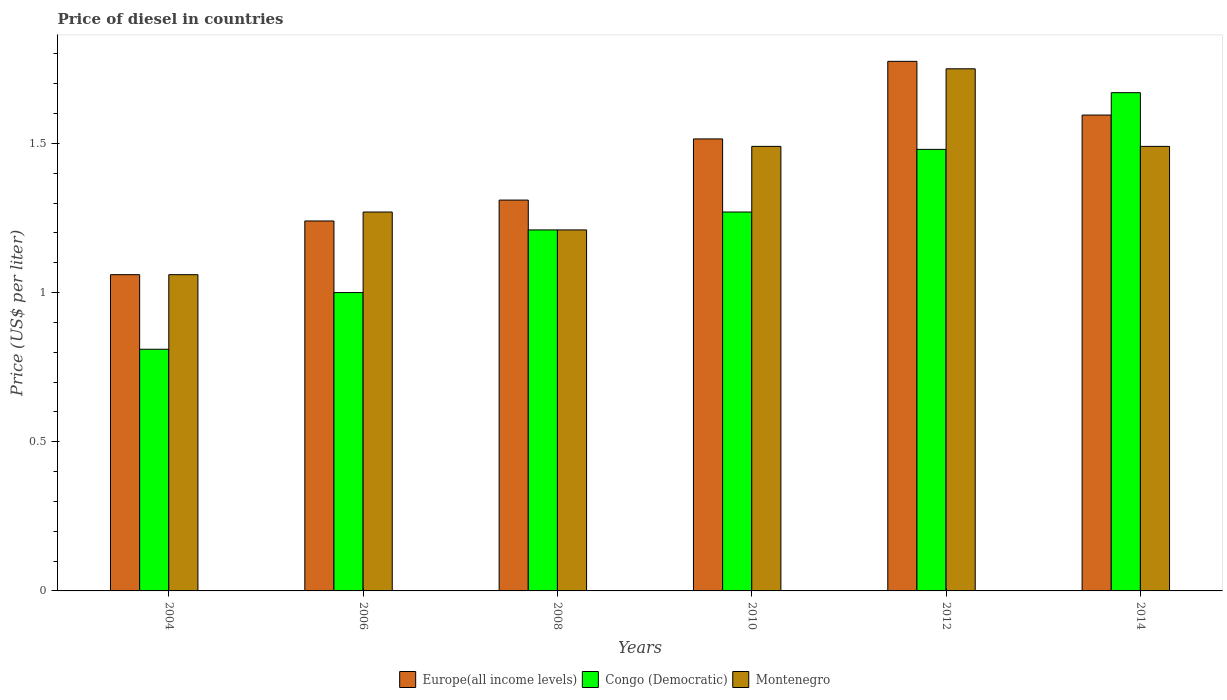How many groups of bars are there?
Your response must be concise. 6. Are the number of bars on each tick of the X-axis equal?
Keep it short and to the point. Yes. What is the price of diesel in Congo (Democratic) in 2004?
Offer a terse response. 0.81. Across all years, what is the maximum price of diesel in Congo (Democratic)?
Ensure brevity in your answer.  1.67. Across all years, what is the minimum price of diesel in Congo (Democratic)?
Keep it short and to the point. 0.81. What is the total price of diesel in Europe(all income levels) in the graph?
Offer a very short reply. 8.5. What is the difference between the price of diesel in Europe(all income levels) in 2006 and that in 2008?
Ensure brevity in your answer.  -0.07. What is the difference between the price of diesel in Congo (Democratic) in 2010 and the price of diesel in Europe(all income levels) in 2006?
Offer a very short reply. 0.03. What is the average price of diesel in Europe(all income levels) per year?
Give a very brief answer. 1.42. In the year 2010, what is the difference between the price of diesel in Congo (Democratic) and price of diesel in Europe(all income levels)?
Make the answer very short. -0.24. In how many years, is the price of diesel in Europe(all income levels) greater than 0.9 US$?
Provide a short and direct response. 6. What is the ratio of the price of diesel in Congo (Democratic) in 2004 to that in 2014?
Offer a very short reply. 0.49. Is the difference between the price of diesel in Congo (Democratic) in 2010 and 2012 greater than the difference between the price of diesel in Europe(all income levels) in 2010 and 2012?
Make the answer very short. Yes. What is the difference between the highest and the second highest price of diesel in Montenegro?
Make the answer very short. 0.26. What is the difference between the highest and the lowest price of diesel in Montenegro?
Give a very brief answer. 0.69. Is the sum of the price of diesel in Montenegro in 2010 and 2012 greater than the maximum price of diesel in Congo (Democratic) across all years?
Offer a very short reply. Yes. What does the 1st bar from the left in 2006 represents?
Provide a short and direct response. Europe(all income levels). What does the 3rd bar from the right in 2008 represents?
Your answer should be very brief. Europe(all income levels). Is it the case that in every year, the sum of the price of diesel in Europe(all income levels) and price of diesel in Congo (Democratic) is greater than the price of diesel in Montenegro?
Offer a very short reply. Yes. Are all the bars in the graph horizontal?
Provide a short and direct response. No. How many years are there in the graph?
Provide a succinct answer. 6. What is the difference between two consecutive major ticks on the Y-axis?
Your response must be concise. 0.5. Are the values on the major ticks of Y-axis written in scientific E-notation?
Your response must be concise. No. Does the graph contain grids?
Your answer should be very brief. No. How many legend labels are there?
Offer a terse response. 3. What is the title of the graph?
Offer a terse response. Price of diesel in countries. Does "India" appear as one of the legend labels in the graph?
Offer a terse response. No. What is the label or title of the Y-axis?
Provide a short and direct response. Price (US$ per liter). What is the Price (US$ per liter) in Europe(all income levels) in 2004?
Offer a terse response. 1.06. What is the Price (US$ per liter) in Congo (Democratic) in 2004?
Give a very brief answer. 0.81. What is the Price (US$ per liter) of Montenegro in 2004?
Your response must be concise. 1.06. What is the Price (US$ per liter) of Europe(all income levels) in 2006?
Ensure brevity in your answer.  1.24. What is the Price (US$ per liter) in Congo (Democratic) in 2006?
Offer a very short reply. 1. What is the Price (US$ per liter) of Montenegro in 2006?
Your answer should be compact. 1.27. What is the Price (US$ per liter) in Europe(all income levels) in 2008?
Your response must be concise. 1.31. What is the Price (US$ per liter) of Congo (Democratic) in 2008?
Your answer should be compact. 1.21. What is the Price (US$ per liter) in Montenegro in 2008?
Ensure brevity in your answer.  1.21. What is the Price (US$ per liter) in Europe(all income levels) in 2010?
Offer a terse response. 1.51. What is the Price (US$ per liter) of Congo (Democratic) in 2010?
Offer a terse response. 1.27. What is the Price (US$ per liter) in Montenegro in 2010?
Your answer should be very brief. 1.49. What is the Price (US$ per liter) of Europe(all income levels) in 2012?
Your answer should be compact. 1.77. What is the Price (US$ per liter) of Congo (Democratic) in 2012?
Make the answer very short. 1.48. What is the Price (US$ per liter) of Montenegro in 2012?
Make the answer very short. 1.75. What is the Price (US$ per liter) in Europe(all income levels) in 2014?
Provide a short and direct response. 1.59. What is the Price (US$ per liter) of Congo (Democratic) in 2014?
Your response must be concise. 1.67. What is the Price (US$ per liter) in Montenegro in 2014?
Give a very brief answer. 1.49. Across all years, what is the maximum Price (US$ per liter) in Europe(all income levels)?
Make the answer very short. 1.77. Across all years, what is the maximum Price (US$ per liter) of Congo (Democratic)?
Your response must be concise. 1.67. Across all years, what is the maximum Price (US$ per liter) of Montenegro?
Keep it short and to the point. 1.75. Across all years, what is the minimum Price (US$ per liter) in Europe(all income levels)?
Give a very brief answer. 1.06. Across all years, what is the minimum Price (US$ per liter) in Congo (Democratic)?
Your answer should be compact. 0.81. Across all years, what is the minimum Price (US$ per liter) of Montenegro?
Your answer should be very brief. 1.06. What is the total Price (US$ per liter) in Europe(all income levels) in the graph?
Make the answer very short. 8.49. What is the total Price (US$ per liter) of Congo (Democratic) in the graph?
Give a very brief answer. 7.44. What is the total Price (US$ per liter) of Montenegro in the graph?
Your answer should be compact. 8.27. What is the difference between the Price (US$ per liter) in Europe(all income levels) in 2004 and that in 2006?
Make the answer very short. -0.18. What is the difference between the Price (US$ per liter) of Congo (Democratic) in 2004 and that in 2006?
Keep it short and to the point. -0.19. What is the difference between the Price (US$ per liter) in Montenegro in 2004 and that in 2006?
Offer a very short reply. -0.21. What is the difference between the Price (US$ per liter) of Europe(all income levels) in 2004 and that in 2008?
Make the answer very short. -0.25. What is the difference between the Price (US$ per liter) in Europe(all income levels) in 2004 and that in 2010?
Make the answer very short. -0.46. What is the difference between the Price (US$ per liter) in Congo (Democratic) in 2004 and that in 2010?
Offer a very short reply. -0.46. What is the difference between the Price (US$ per liter) in Montenegro in 2004 and that in 2010?
Give a very brief answer. -0.43. What is the difference between the Price (US$ per liter) in Europe(all income levels) in 2004 and that in 2012?
Ensure brevity in your answer.  -0.71. What is the difference between the Price (US$ per liter) in Congo (Democratic) in 2004 and that in 2012?
Your answer should be compact. -0.67. What is the difference between the Price (US$ per liter) of Montenegro in 2004 and that in 2012?
Offer a terse response. -0.69. What is the difference between the Price (US$ per liter) of Europe(all income levels) in 2004 and that in 2014?
Offer a terse response. -0.54. What is the difference between the Price (US$ per liter) of Congo (Democratic) in 2004 and that in 2014?
Your response must be concise. -0.86. What is the difference between the Price (US$ per liter) in Montenegro in 2004 and that in 2014?
Offer a very short reply. -0.43. What is the difference between the Price (US$ per liter) in Europe(all income levels) in 2006 and that in 2008?
Make the answer very short. -0.07. What is the difference between the Price (US$ per liter) in Congo (Democratic) in 2006 and that in 2008?
Your answer should be very brief. -0.21. What is the difference between the Price (US$ per liter) in Europe(all income levels) in 2006 and that in 2010?
Keep it short and to the point. -0.28. What is the difference between the Price (US$ per liter) of Congo (Democratic) in 2006 and that in 2010?
Your response must be concise. -0.27. What is the difference between the Price (US$ per liter) in Montenegro in 2006 and that in 2010?
Provide a succinct answer. -0.22. What is the difference between the Price (US$ per liter) of Europe(all income levels) in 2006 and that in 2012?
Your answer should be very brief. -0.54. What is the difference between the Price (US$ per liter) in Congo (Democratic) in 2006 and that in 2012?
Your answer should be very brief. -0.48. What is the difference between the Price (US$ per liter) in Montenegro in 2006 and that in 2012?
Your answer should be compact. -0.48. What is the difference between the Price (US$ per liter) of Europe(all income levels) in 2006 and that in 2014?
Ensure brevity in your answer.  -0.35. What is the difference between the Price (US$ per liter) in Congo (Democratic) in 2006 and that in 2014?
Offer a terse response. -0.67. What is the difference between the Price (US$ per liter) in Montenegro in 2006 and that in 2014?
Offer a terse response. -0.22. What is the difference between the Price (US$ per liter) of Europe(all income levels) in 2008 and that in 2010?
Keep it short and to the point. -0.2. What is the difference between the Price (US$ per liter) of Congo (Democratic) in 2008 and that in 2010?
Your answer should be compact. -0.06. What is the difference between the Price (US$ per liter) of Montenegro in 2008 and that in 2010?
Provide a short and direct response. -0.28. What is the difference between the Price (US$ per liter) in Europe(all income levels) in 2008 and that in 2012?
Your answer should be compact. -0.47. What is the difference between the Price (US$ per liter) of Congo (Democratic) in 2008 and that in 2012?
Provide a succinct answer. -0.27. What is the difference between the Price (US$ per liter) of Montenegro in 2008 and that in 2012?
Your answer should be compact. -0.54. What is the difference between the Price (US$ per liter) in Europe(all income levels) in 2008 and that in 2014?
Your response must be concise. -0.28. What is the difference between the Price (US$ per liter) in Congo (Democratic) in 2008 and that in 2014?
Give a very brief answer. -0.46. What is the difference between the Price (US$ per liter) in Montenegro in 2008 and that in 2014?
Ensure brevity in your answer.  -0.28. What is the difference between the Price (US$ per liter) of Europe(all income levels) in 2010 and that in 2012?
Ensure brevity in your answer.  -0.26. What is the difference between the Price (US$ per liter) in Congo (Democratic) in 2010 and that in 2012?
Your answer should be compact. -0.21. What is the difference between the Price (US$ per liter) in Montenegro in 2010 and that in 2012?
Your answer should be compact. -0.26. What is the difference between the Price (US$ per liter) of Europe(all income levels) in 2010 and that in 2014?
Provide a short and direct response. -0.08. What is the difference between the Price (US$ per liter) of Montenegro in 2010 and that in 2014?
Offer a terse response. 0. What is the difference between the Price (US$ per liter) in Europe(all income levels) in 2012 and that in 2014?
Provide a succinct answer. 0.18. What is the difference between the Price (US$ per liter) of Congo (Democratic) in 2012 and that in 2014?
Provide a succinct answer. -0.19. What is the difference between the Price (US$ per liter) in Montenegro in 2012 and that in 2014?
Give a very brief answer. 0.26. What is the difference between the Price (US$ per liter) of Europe(all income levels) in 2004 and the Price (US$ per liter) of Montenegro in 2006?
Your answer should be compact. -0.21. What is the difference between the Price (US$ per liter) of Congo (Democratic) in 2004 and the Price (US$ per liter) of Montenegro in 2006?
Keep it short and to the point. -0.46. What is the difference between the Price (US$ per liter) of Europe(all income levels) in 2004 and the Price (US$ per liter) of Congo (Democratic) in 2008?
Offer a terse response. -0.15. What is the difference between the Price (US$ per liter) of Congo (Democratic) in 2004 and the Price (US$ per liter) of Montenegro in 2008?
Keep it short and to the point. -0.4. What is the difference between the Price (US$ per liter) in Europe(all income levels) in 2004 and the Price (US$ per liter) in Congo (Democratic) in 2010?
Your answer should be very brief. -0.21. What is the difference between the Price (US$ per liter) of Europe(all income levels) in 2004 and the Price (US$ per liter) of Montenegro in 2010?
Make the answer very short. -0.43. What is the difference between the Price (US$ per liter) of Congo (Democratic) in 2004 and the Price (US$ per liter) of Montenegro in 2010?
Provide a short and direct response. -0.68. What is the difference between the Price (US$ per liter) in Europe(all income levels) in 2004 and the Price (US$ per liter) in Congo (Democratic) in 2012?
Offer a terse response. -0.42. What is the difference between the Price (US$ per liter) of Europe(all income levels) in 2004 and the Price (US$ per liter) of Montenegro in 2012?
Make the answer very short. -0.69. What is the difference between the Price (US$ per liter) in Congo (Democratic) in 2004 and the Price (US$ per liter) in Montenegro in 2012?
Offer a terse response. -0.94. What is the difference between the Price (US$ per liter) in Europe(all income levels) in 2004 and the Price (US$ per liter) in Congo (Democratic) in 2014?
Your response must be concise. -0.61. What is the difference between the Price (US$ per liter) of Europe(all income levels) in 2004 and the Price (US$ per liter) of Montenegro in 2014?
Ensure brevity in your answer.  -0.43. What is the difference between the Price (US$ per liter) in Congo (Democratic) in 2004 and the Price (US$ per liter) in Montenegro in 2014?
Your response must be concise. -0.68. What is the difference between the Price (US$ per liter) of Europe(all income levels) in 2006 and the Price (US$ per liter) of Congo (Democratic) in 2008?
Offer a terse response. 0.03. What is the difference between the Price (US$ per liter) of Europe(all income levels) in 2006 and the Price (US$ per liter) of Montenegro in 2008?
Offer a terse response. 0.03. What is the difference between the Price (US$ per liter) of Congo (Democratic) in 2006 and the Price (US$ per liter) of Montenegro in 2008?
Offer a terse response. -0.21. What is the difference between the Price (US$ per liter) of Europe(all income levels) in 2006 and the Price (US$ per liter) of Congo (Democratic) in 2010?
Your response must be concise. -0.03. What is the difference between the Price (US$ per liter) of Congo (Democratic) in 2006 and the Price (US$ per liter) of Montenegro in 2010?
Your answer should be compact. -0.49. What is the difference between the Price (US$ per liter) of Europe(all income levels) in 2006 and the Price (US$ per liter) of Congo (Democratic) in 2012?
Your answer should be very brief. -0.24. What is the difference between the Price (US$ per liter) of Europe(all income levels) in 2006 and the Price (US$ per liter) of Montenegro in 2012?
Make the answer very short. -0.51. What is the difference between the Price (US$ per liter) of Congo (Democratic) in 2006 and the Price (US$ per liter) of Montenegro in 2012?
Keep it short and to the point. -0.75. What is the difference between the Price (US$ per liter) of Europe(all income levels) in 2006 and the Price (US$ per liter) of Congo (Democratic) in 2014?
Make the answer very short. -0.43. What is the difference between the Price (US$ per liter) in Europe(all income levels) in 2006 and the Price (US$ per liter) in Montenegro in 2014?
Offer a very short reply. -0.25. What is the difference between the Price (US$ per liter) of Congo (Democratic) in 2006 and the Price (US$ per liter) of Montenegro in 2014?
Provide a short and direct response. -0.49. What is the difference between the Price (US$ per liter) in Europe(all income levels) in 2008 and the Price (US$ per liter) in Montenegro in 2010?
Make the answer very short. -0.18. What is the difference between the Price (US$ per liter) in Congo (Democratic) in 2008 and the Price (US$ per liter) in Montenegro in 2010?
Your answer should be compact. -0.28. What is the difference between the Price (US$ per liter) in Europe(all income levels) in 2008 and the Price (US$ per liter) in Congo (Democratic) in 2012?
Provide a succinct answer. -0.17. What is the difference between the Price (US$ per liter) of Europe(all income levels) in 2008 and the Price (US$ per liter) of Montenegro in 2012?
Your answer should be very brief. -0.44. What is the difference between the Price (US$ per liter) in Congo (Democratic) in 2008 and the Price (US$ per liter) in Montenegro in 2012?
Your answer should be very brief. -0.54. What is the difference between the Price (US$ per liter) in Europe(all income levels) in 2008 and the Price (US$ per liter) in Congo (Democratic) in 2014?
Your answer should be very brief. -0.36. What is the difference between the Price (US$ per liter) in Europe(all income levels) in 2008 and the Price (US$ per liter) in Montenegro in 2014?
Provide a short and direct response. -0.18. What is the difference between the Price (US$ per liter) of Congo (Democratic) in 2008 and the Price (US$ per liter) of Montenegro in 2014?
Ensure brevity in your answer.  -0.28. What is the difference between the Price (US$ per liter) in Europe(all income levels) in 2010 and the Price (US$ per liter) in Congo (Democratic) in 2012?
Your answer should be very brief. 0.04. What is the difference between the Price (US$ per liter) of Europe(all income levels) in 2010 and the Price (US$ per liter) of Montenegro in 2012?
Your answer should be compact. -0.23. What is the difference between the Price (US$ per liter) in Congo (Democratic) in 2010 and the Price (US$ per liter) in Montenegro in 2012?
Make the answer very short. -0.48. What is the difference between the Price (US$ per liter) in Europe(all income levels) in 2010 and the Price (US$ per liter) in Congo (Democratic) in 2014?
Give a very brief answer. -0.15. What is the difference between the Price (US$ per liter) in Europe(all income levels) in 2010 and the Price (US$ per liter) in Montenegro in 2014?
Give a very brief answer. 0.03. What is the difference between the Price (US$ per liter) in Congo (Democratic) in 2010 and the Price (US$ per liter) in Montenegro in 2014?
Offer a very short reply. -0.22. What is the difference between the Price (US$ per liter) in Europe(all income levels) in 2012 and the Price (US$ per liter) in Congo (Democratic) in 2014?
Offer a terse response. 0.1. What is the difference between the Price (US$ per liter) in Europe(all income levels) in 2012 and the Price (US$ per liter) in Montenegro in 2014?
Provide a short and direct response. 0.28. What is the difference between the Price (US$ per liter) in Congo (Democratic) in 2012 and the Price (US$ per liter) in Montenegro in 2014?
Ensure brevity in your answer.  -0.01. What is the average Price (US$ per liter) in Europe(all income levels) per year?
Provide a succinct answer. 1.42. What is the average Price (US$ per liter) of Congo (Democratic) per year?
Ensure brevity in your answer.  1.24. What is the average Price (US$ per liter) in Montenegro per year?
Offer a very short reply. 1.38. In the year 2004, what is the difference between the Price (US$ per liter) of Europe(all income levels) and Price (US$ per liter) of Congo (Democratic)?
Provide a succinct answer. 0.25. In the year 2004, what is the difference between the Price (US$ per liter) of Europe(all income levels) and Price (US$ per liter) of Montenegro?
Ensure brevity in your answer.  0. In the year 2004, what is the difference between the Price (US$ per liter) in Congo (Democratic) and Price (US$ per liter) in Montenegro?
Ensure brevity in your answer.  -0.25. In the year 2006, what is the difference between the Price (US$ per liter) in Europe(all income levels) and Price (US$ per liter) in Congo (Democratic)?
Offer a very short reply. 0.24. In the year 2006, what is the difference between the Price (US$ per liter) of Europe(all income levels) and Price (US$ per liter) of Montenegro?
Keep it short and to the point. -0.03. In the year 2006, what is the difference between the Price (US$ per liter) of Congo (Democratic) and Price (US$ per liter) of Montenegro?
Provide a short and direct response. -0.27. In the year 2008, what is the difference between the Price (US$ per liter) of Europe(all income levels) and Price (US$ per liter) of Congo (Democratic)?
Provide a succinct answer. 0.1. In the year 2010, what is the difference between the Price (US$ per liter) in Europe(all income levels) and Price (US$ per liter) in Congo (Democratic)?
Your response must be concise. 0.24. In the year 2010, what is the difference between the Price (US$ per liter) in Europe(all income levels) and Price (US$ per liter) in Montenegro?
Provide a succinct answer. 0.03. In the year 2010, what is the difference between the Price (US$ per liter) in Congo (Democratic) and Price (US$ per liter) in Montenegro?
Keep it short and to the point. -0.22. In the year 2012, what is the difference between the Price (US$ per liter) in Europe(all income levels) and Price (US$ per liter) in Congo (Democratic)?
Your answer should be very brief. 0.29. In the year 2012, what is the difference between the Price (US$ per liter) of Europe(all income levels) and Price (US$ per liter) of Montenegro?
Provide a succinct answer. 0.03. In the year 2012, what is the difference between the Price (US$ per liter) in Congo (Democratic) and Price (US$ per liter) in Montenegro?
Your response must be concise. -0.27. In the year 2014, what is the difference between the Price (US$ per liter) in Europe(all income levels) and Price (US$ per liter) in Congo (Democratic)?
Your answer should be compact. -0.07. In the year 2014, what is the difference between the Price (US$ per liter) in Europe(all income levels) and Price (US$ per liter) in Montenegro?
Offer a terse response. 0.1. In the year 2014, what is the difference between the Price (US$ per liter) in Congo (Democratic) and Price (US$ per liter) in Montenegro?
Ensure brevity in your answer.  0.18. What is the ratio of the Price (US$ per liter) of Europe(all income levels) in 2004 to that in 2006?
Provide a short and direct response. 0.85. What is the ratio of the Price (US$ per liter) in Congo (Democratic) in 2004 to that in 2006?
Give a very brief answer. 0.81. What is the ratio of the Price (US$ per liter) in Montenegro in 2004 to that in 2006?
Give a very brief answer. 0.83. What is the ratio of the Price (US$ per liter) of Europe(all income levels) in 2004 to that in 2008?
Keep it short and to the point. 0.81. What is the ratio of the Price (US$ per liter) in Congo (Democratic) in 2004 to that in 2008?
Keep it short and to the point. 0.67. What is the ratio of the Price (US$ per liter) in Montenegro in 2004 to that in 2008?
Your answer should be very brief. 0.88. What is the ratio of the Price (US$ per liter) in Europe(all income levels) in 2004 to that in 2010?
Provide a short and direct response. 0.7. What is the ratio of the Price (US$ per liter) of Congo (Democratic) in 2004 to that in 2010?
Offer a very short reply. 0.64. What is the ratio of the Price (US$ per liter) in Montenegro in 2004 to that in 2010?
Offer a terse response. 0.71. What is the ratio of the Price (US$ per liter) of Europe(all income levels) in 2004 to that in 2012?
Ensure brevity in your answer.  0.6. What is the ratio of the Price (US$ per liter) in Congo (Democratic) in 2004 to that in 2012?
Make the answer very short. 0.55. What is the ratio of the Price (US$ per liter) of Montenegro in 2004 to that in 2012?
Offer a terse response. 0.61. What is the ratio of the Price (US$ per liter) of Europe(all income levels) in 2004 to that in 2014?
Ensure brevity in your answer.  0.66. What is the ratio of the Price (US$ per liter) of Congo (Democratic) in 2004 to that in 2014?
Your answer should be compact. 0.48. What is the ratio of the Price (US$ per liter) in Montenegro in 2004 to that in 2014?
Your answer should be very brief. 0.71. What is the ratio of the Price (US$ per liter) in Europe(all income levels) in 2006 to that in 2008?
Give a very brief answer. 0.95. What is the ratio of the Price (US$ per liter) of Congo (Democratic) in 2006 to that in 2008?
Offer a terse response. 0.83. What is the ratio of the Price (US$ per liter) of Montenegro in 2006 to that in 2008?
Offer a terse response. 1.05. What is the ratio of the Price (US$ per liter) of Europe(all income levels) in 2006 to that in 2010?
Make the answer very short. 0.82. What is the ratio of the Price (US$ per liter) in Congo (Democratic) in 2006 to that in 2010?
Make the answer very short. 0.79. What is the ratio of the Price (US$ per liter) of Montenegro in 2006 to that in 2010?
Your response must be concise. 0.85. What is the ratio of the Price (US$ per liter) of Europe(all income levels) in 2006 to that in 2012?
Your response must be concise. 0.7. What is the ratio of the Price (US$ per liter) of Congo (Democratic) in 2006 to that in 2012?
Offer a terse response. 0.68. What is the ratio of the Price (US$ per liter) of Montenegro in 2006 to that in 2012?
Make the answer very short. 0.73. What is the ratio of the Price (US$ per liter) in Europe(all income levels) in 2006 to that in 2014?
Provide a short and direct response. 0.78. What is the ratio of the Price (US$ per liter) in Congo (Democratic) in 2006 to that in 2014?
Your answer should be compact. 0.6. What is the ratio of the Price (US$ per liter) of Montenegro in 2006 to that in 2014?
Your answer should be compact. 0.85. What is the ratio of the Price (US$ per liter) in Europe(all income levels) in 2008 to that in 2010?
Provide a short and direct response. 0.86. What is the ratio of the Price (US$ per liter) of Congo (Democratic) in 2008 to that in 2010?
Give a very brief answer. 0.95. What is the ratio of the Price (US$ per liter) in Montenegro in 2008 to that in 2010?
Your answer should be compact. 0.81. What is the ratio of the Price (US$ per liter) in Europe(all income levels) in 2008 to that in 2012?
Offer a terse response. 0.74. What is the ratio of the Price (US$ per liter) in Congo (Democratic) in 2008 to that in 2012?
Your answer should be very brief. 0.82. What is the ratio of the Price (US$ per liter) of Montenegro in 2008 to that in 2012?
Provide a short and direct response. 0.69. What is the ratio of the Price (US$ per liter) in Europe(all income levels) in 2008 to that in 2014?
Your answer should be compact. 0.82. What is the ratio of the Price (US$ per liter) in Congo (Democratic) in 2008 to that in 2014?
Provide a succinct answer. 0.72. What is the ratio of the Price (US$ per liter) in Montenegro in 2008 to that in 2014?
Make the answer very short. 0.81. What is the ratio of the Price (US$ per liter) in Europe(all income levels) in 2010 to that in 2012?
Keep it short and to the point. 0.85. What is the ratio of the Price (US$ per liter) of Congo (Democratic) in 2010 to that in 2012?
Provide a succinct answer. 0.86. What is the ratio of the Price (US$ per liter) in Montenegro in 2010 to that in 2012?
Keep it short and to the point. 0.85. What is the ratio of the Price (US$ per liter) of Europe(all income levels) in 2010 to that in 2014?
Keep it short and to the point. 0.95. What is the ratio of the Price (US$ per liter) of Congo (Democratic) in 2010 to that in 2014?
Offer a terse response. 0.76. What is the ratio of the Price (US$ per liter) in Europe(all income levels) in 2012 to that in 2014?
Offer a very short reply. 1.11. What is the ratio of the Price (US$ per liter) in Congo (Democratic) in 2012 to that in 2014?
Offer a terse response. 0.89. What is the ratio of the Price (US$ per liter) of Montenegro in 2012 to that in 2014?
Your response must be concise. 1.17. What is the difference between the highest and the second highest Price (US$ per liter) of Europe(all income levels)?
Provide a succinct answer. 0.18. What is the difference between the highest and the second highest Price (US$ per liter) in Congo (Democratic)?
Ensure brevity in your answer.  0.19. What is the difference between the highest and the second highest Price (US$ per liter) of Montenegro?
Make the answer very short. 0.26. What is the difference between the highest and the lowest Price (US$ per liter) of Europe(all income levels)?
Ensure brevity in your answer.  0.71. What is the difference between the highest and the lowest Price (US$ per liter) of Congo (Democratic)?
Your answer should be compact. 0.86. What is the difference between the highest and the lowest Price (US$ per liter) in Montenegro?
Your answer should be compact. 0.69. 